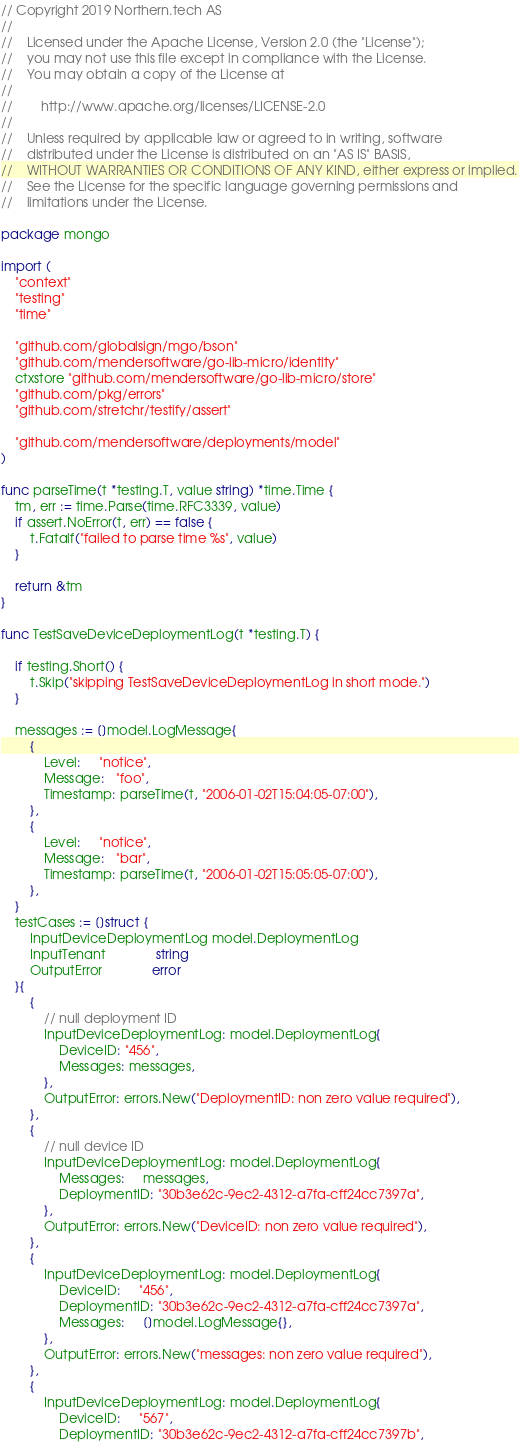<code> <loc_0><loc_0><loc_500><loc_500><_Go_>// Copyright 2019 Northern.tech AS
//
//    Licensed under the Apache License, Version 2.0 (the "License");
//    you may not use this file except in compliance with the License.
//    You may obtain a copy of the License at
//
//        http://www.apache.org/licenses/LICENSE-2.0
//
//    Unless required by applicable law or agreed to in writing, software
//    distributed under the License is distributed on an "AS IS" BASIS,
//    WITHOUT WARRANTIES OR CONDITIONS OF ANY KIND, either express or implied.
//    See the License for the specific language governing permissions and
//    limitations under the License.

package mongo

import (
	"context"
	"testing"
	"time"

	"github.com/globalsign/mgo/bson"
	"github.com/mendersoftware/go-lib-micro/identity"
	ctxstore "github.com/mendersoftware/go-lib-micro/store"
	"github.com/pkg/errors"
	"github.com/stretchr/testify/assert"

	"github.com/mendersoftware/deployments/model"
)

func parseTime(t *testing.T, value string) *time.Time {
	tm, err := time.Parse(time.RFC3339, value)
	if assert.NoError(t, err) == false {
		t.Fatalf("failed to parse time %s", value)
	}

	return &tm
}

func TestSaveDeviceDeploymentLog(t *testing.T) {

	if testing.Short() {
		t.Skip("skipping TestSaveDeviceDeploymentLog in short mode.")
	}

	messages := []model.LogMessage{
		{
			Level:     "notice",
			Message:   "foo",
			Timestamp: parseTime(t, "2006-01-02T15:04:05-07:00"),
		},
		{
			Level:     "notice",
			Message:   "bar",
			Timestamp: parseTime(t, "2006-01-02T15:05:05-07:00"),
		},
	}
	testCases := []struct {
		InputDeviceDeploymentLog model.DeploymentLog
		InputTenant              string
		OutputError              error
	}{
		{
			// null deployment ID
			InputDeviceDeploymentLog: model.DeploymentLog{
				DeviceID: "456",
				Messages: messages,
			},
			OutputError: errors.New("DeploymentID: non zero value required"),
		},
		{
			// null device ID
			InputDeviceDeploymentLog: model.DeploymentLog{
				Messages:     messages,
				DeploymentID: "30b3e62c-9ec2-4312-a7fa-cff24cc7397a",
			},
			OutputError: errors.New("DeviceID: non zero value required"),
		},
		{
			InputDeviceDeploymentLog: model.DeploymentLog{
				DeviceID:     "456",
				DeploymentID: "30b3e62c-9ec2-4312-a7fa-cff24cc7397a",
				Messages:     []model.LogMessage{},
			},
			OutputError: errors.New("messages: non zero value required"),
		},
		{
			InputDeviceDeploymentLog: model.DeploymentLog{
				DeviceID:     "567",
				DeploymentID: "30b3e62c-9ec2-4312-a7fa-cff24cc7397b",</code> 